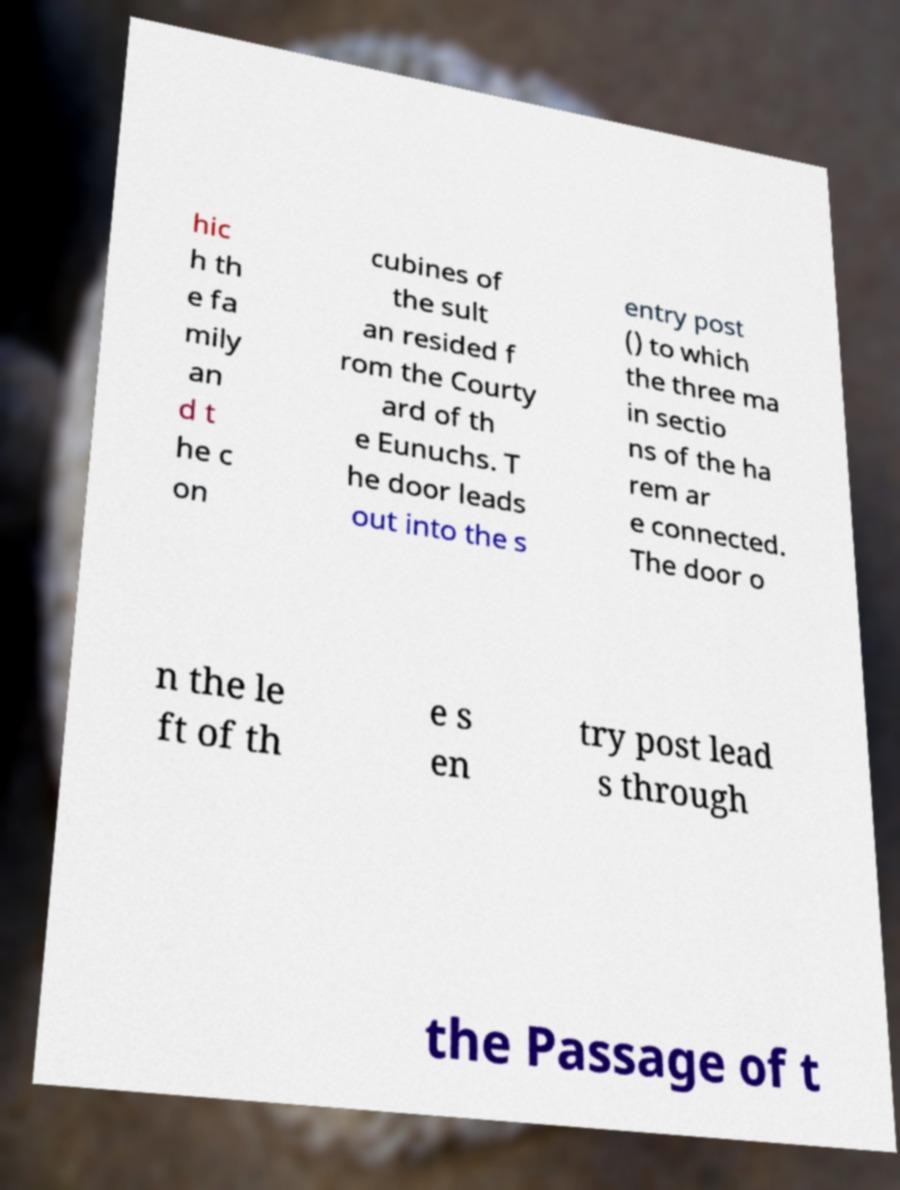Please read and relay the text visible in this image. What does it say? hic h th e fa mily an d t he c on cubines of the sult an resided f rom the Courty ard of th e Eunuchs. T he door leads out into the s entry post () to which the three ma in sectio ns of the ha rem ar e connected. The door o n the le ft of th e s en try post lead s through the Passage of t 